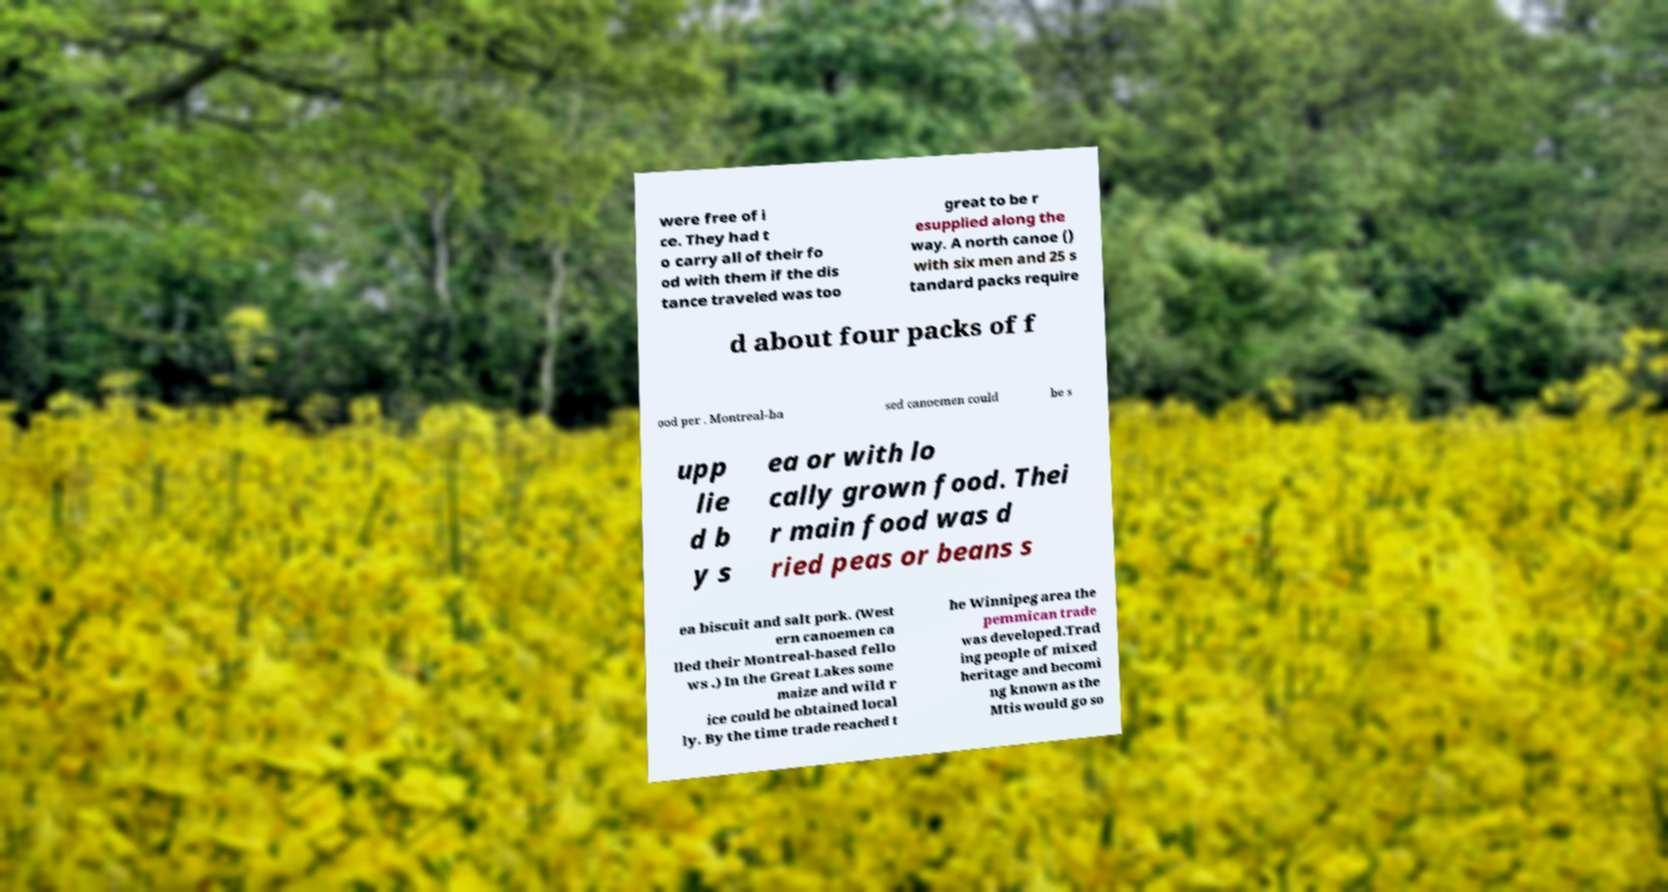Please identify and transcribe the text found in this image. were free of i ce. They had t o carry all of their fo od with them if the dis tance traveled was too great to be r esupplied along the way. A north canoe () with six men and 25 s tandard packs require d about four packs of f ood per . Montreal-ba sed canoemen could be s upp lie d b y s ea or with lo cally grown food. Thei r main food was d ried peas or beans s ea biscuit and salt pork. (West ern canoemen ca lled their Montreal-based fello ws .) In the Great Lakes some maize and wild r ice could be obtained local ly. By the time trade reached t he Winnipeg area the pemmican trade was developed.Trad ing people of mixed heritage and becomi ng known as the Mtis would go so 